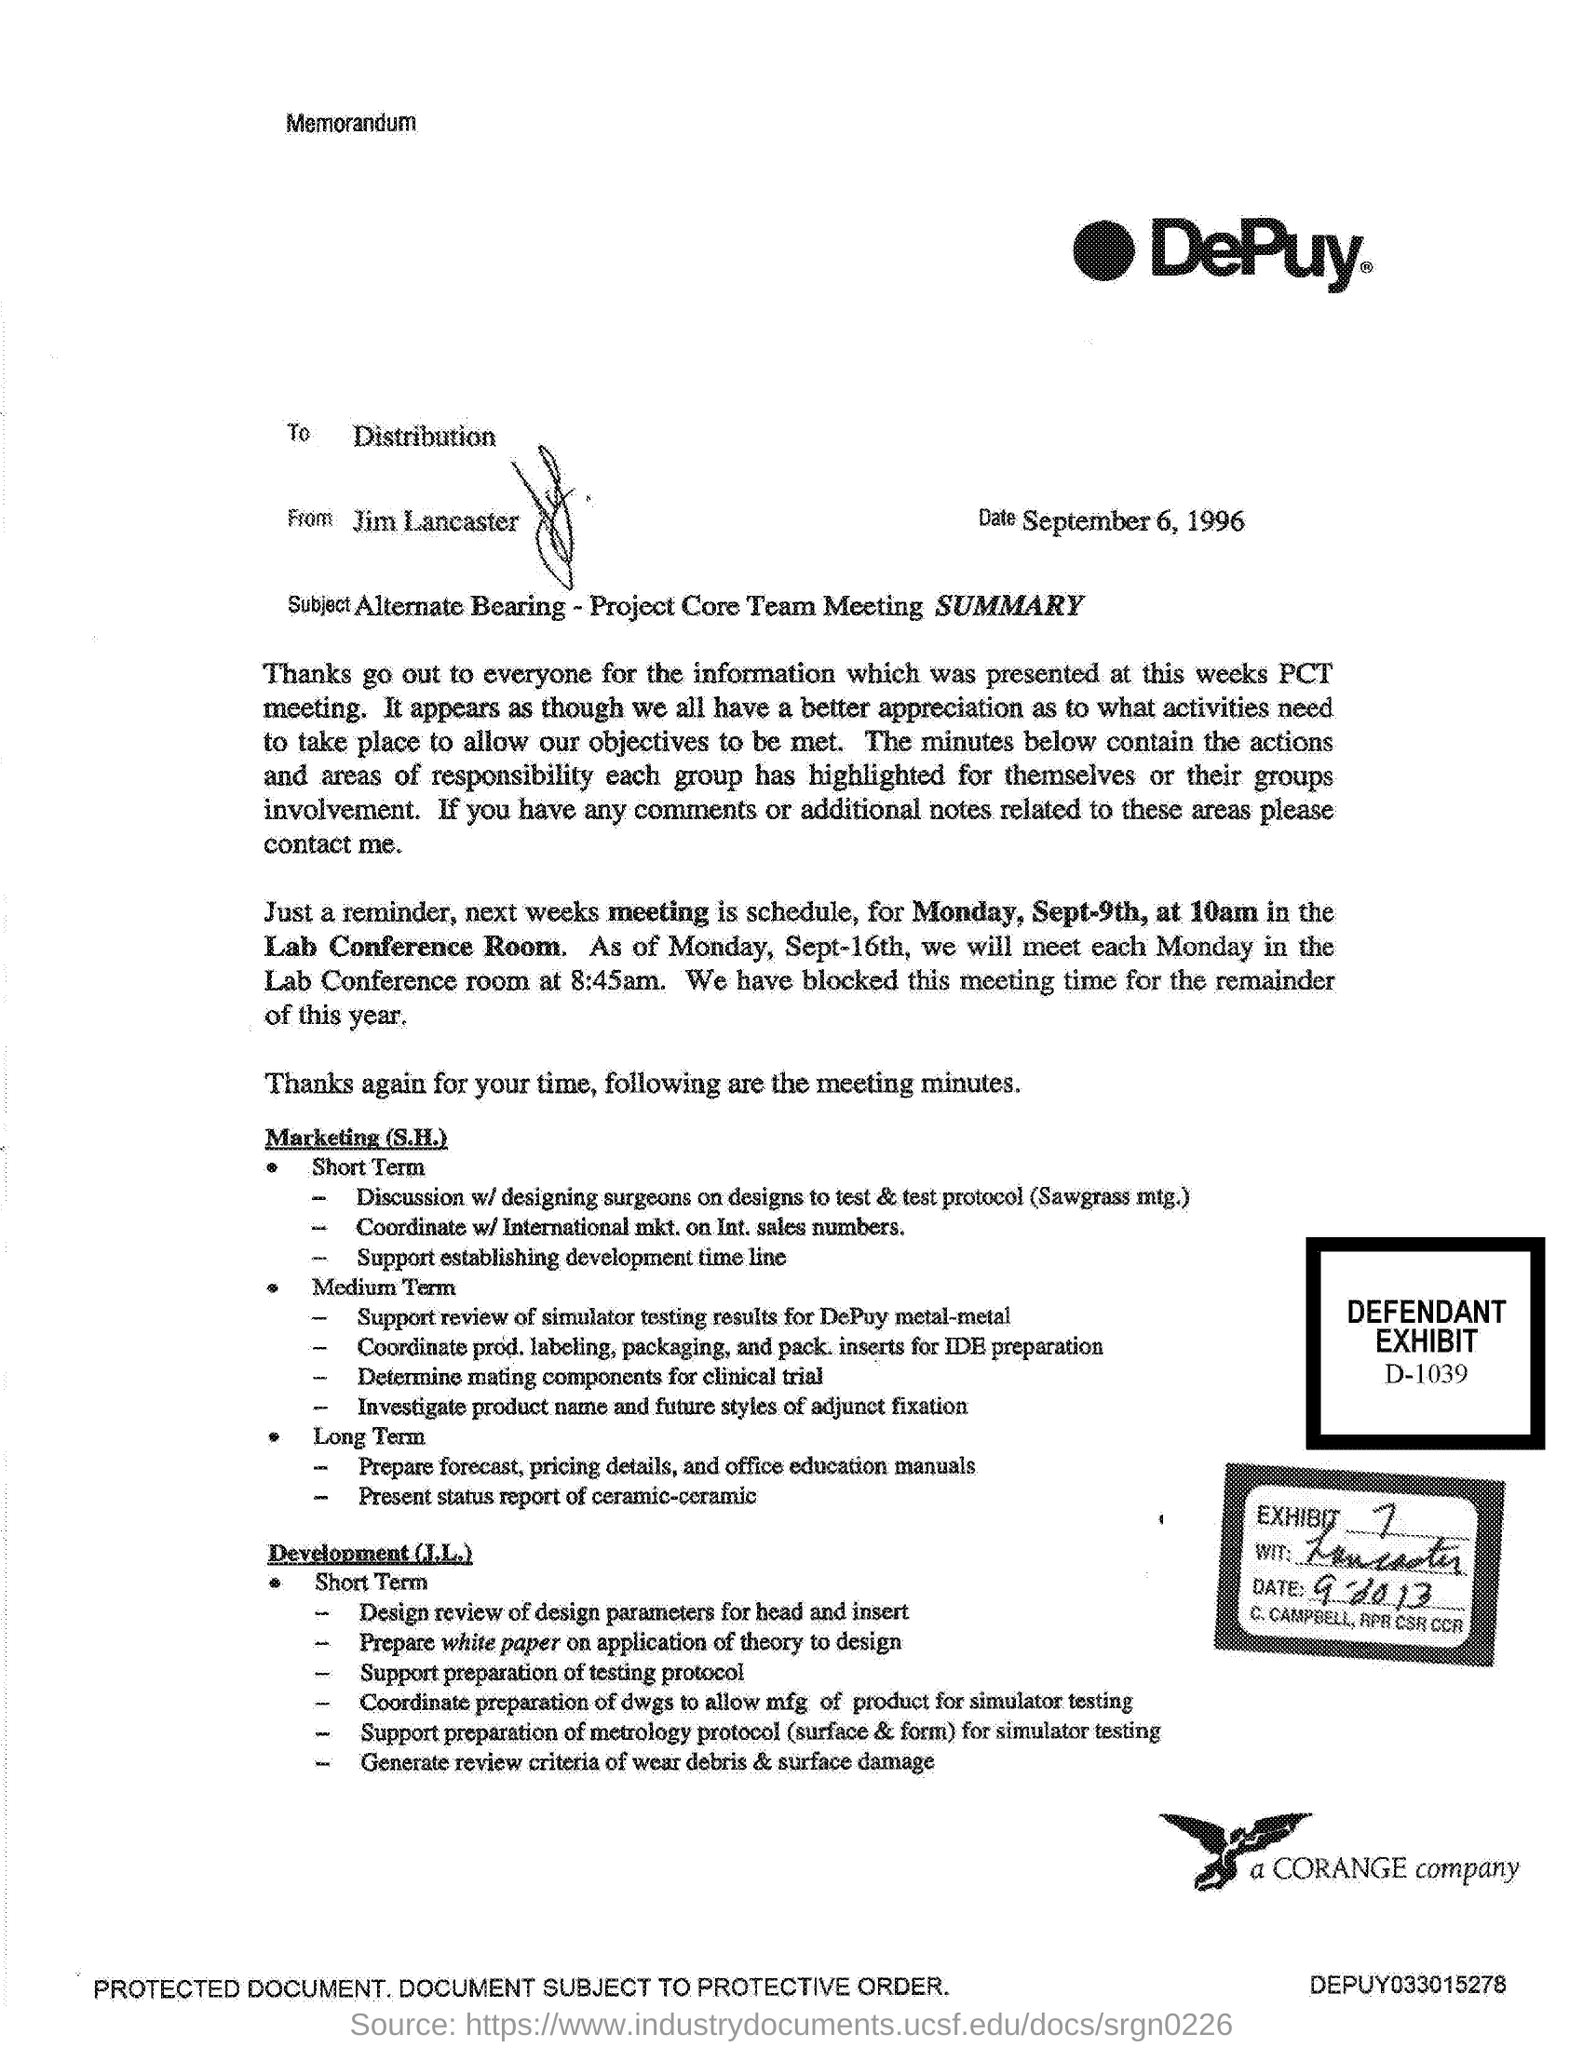What kind of communication is this?
Your response must be concise. Memorandum. Which company's memorandum is given here?
Offer a terse response. DePuy. Who is the sender of this memorandum?
Offer a very short reply. Jim Lancaster. To whom, the memorandum is addressed?
Make the answer very short. Distribution. What is the defendant exhibit no. given in the document?
Offer a terse response. D-1039. 